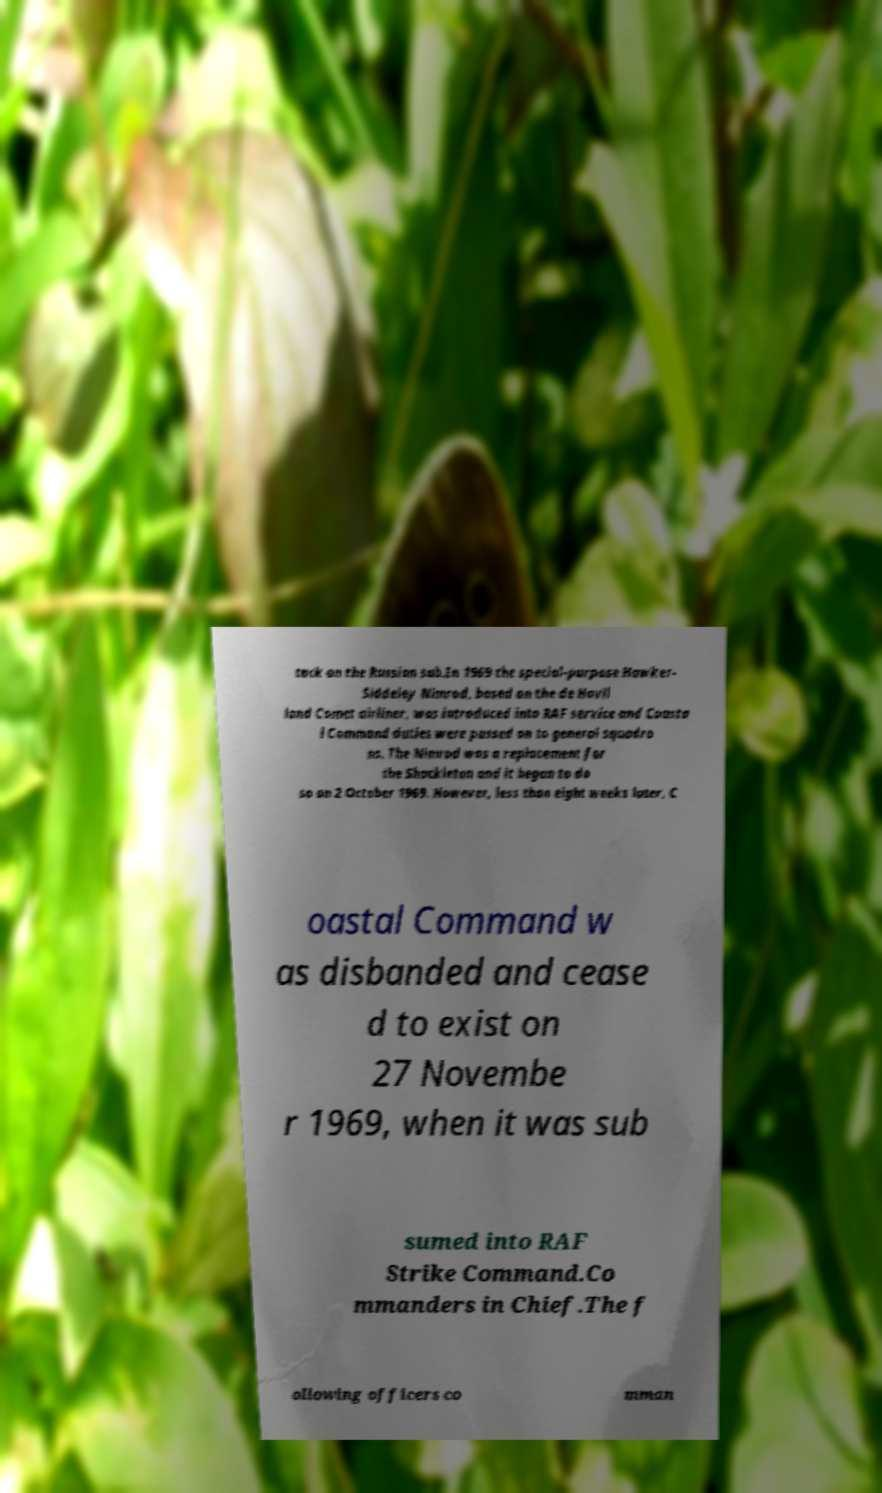Could you extract and type out the text from this image? tack on the Russian sub.In 1969 the special-purpose Hawker- Siddeley Nimrod, based on the de Havil land Comet airliner, was introduced into RAF service and Coasta l Command duties were passed on to general squadro ns. The Nimrod was a replacement for the Shackleton and it began to do so on 2 October 1969. However, less than eight weeks later, C oastal Command w as disbanded and cease d to exist on 27 Novembe r 1969, when it was sub sumed into RAF Strike Command.Co mmanders in Chief.The f ollowing officers co mman 